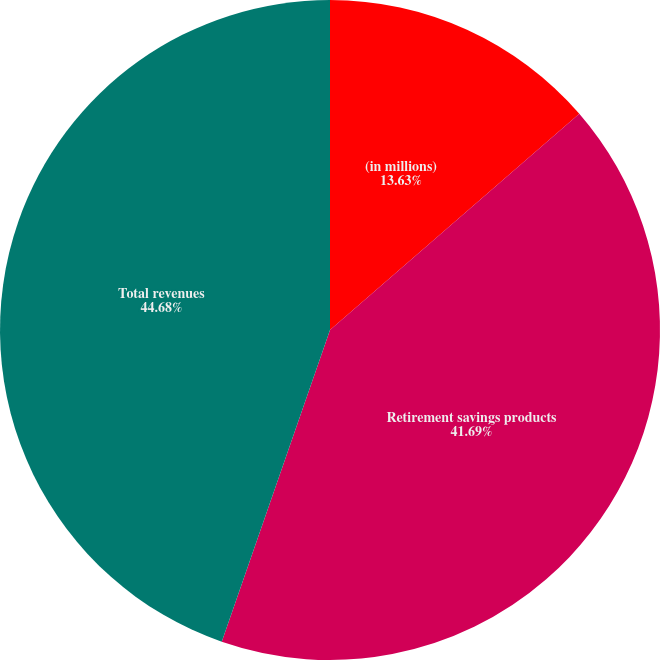Convert chart. <chart><loc_0><loc_0><loc_500><loc_500><pie_chart><fcel>(in millions)<fcel>Retirement savings products<fcel>Total revenues<nl><fcel>13.63%<fcel>41.69%<fcel>44.68%<nl></chart> 